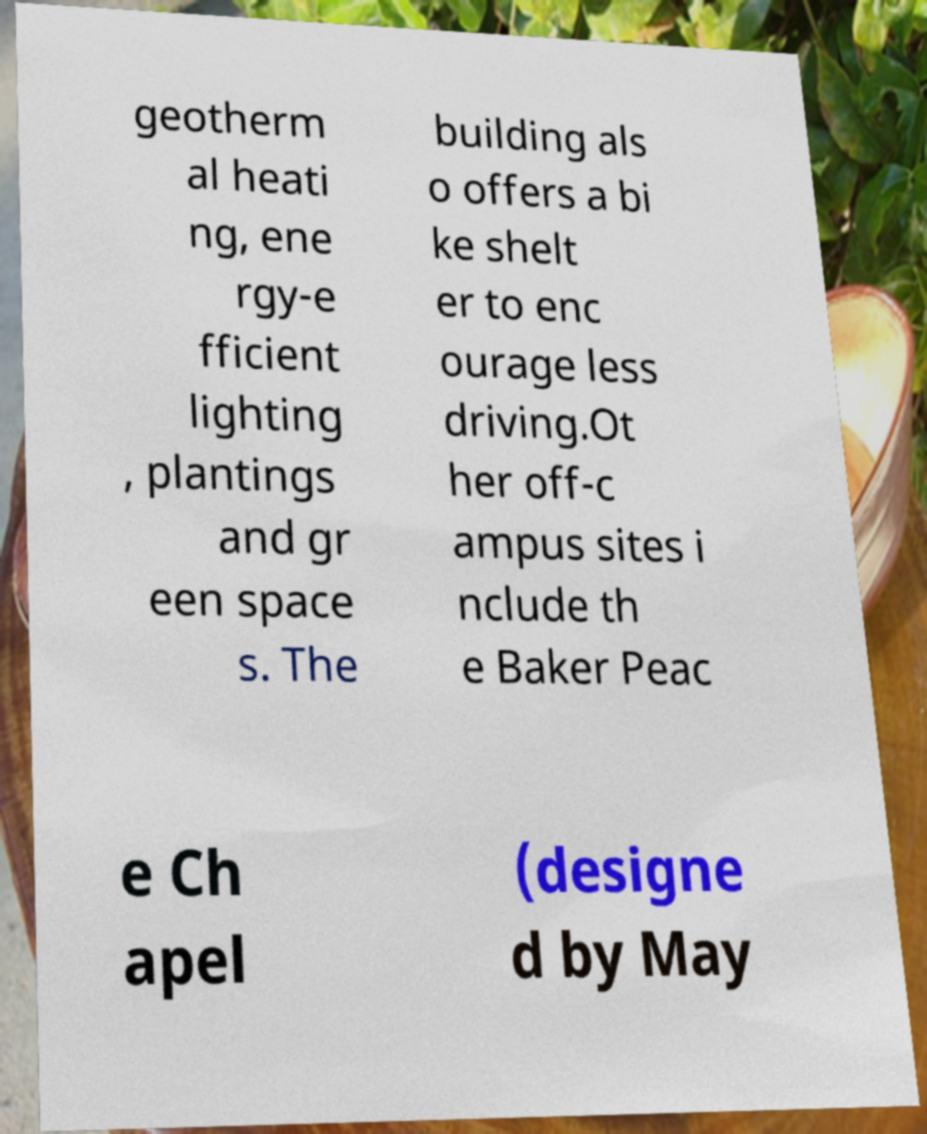Please read and relay the text visible in this image. What does it say? geotherm al heati ng, ene rgy-e fficient lighting , plantings and gr een space s. The building als o offers a bi ke shelt er to enc ourage less driving.Ot her off-c ampus sites i nclude th e Baker Peac e Ch apel (designe d by May 